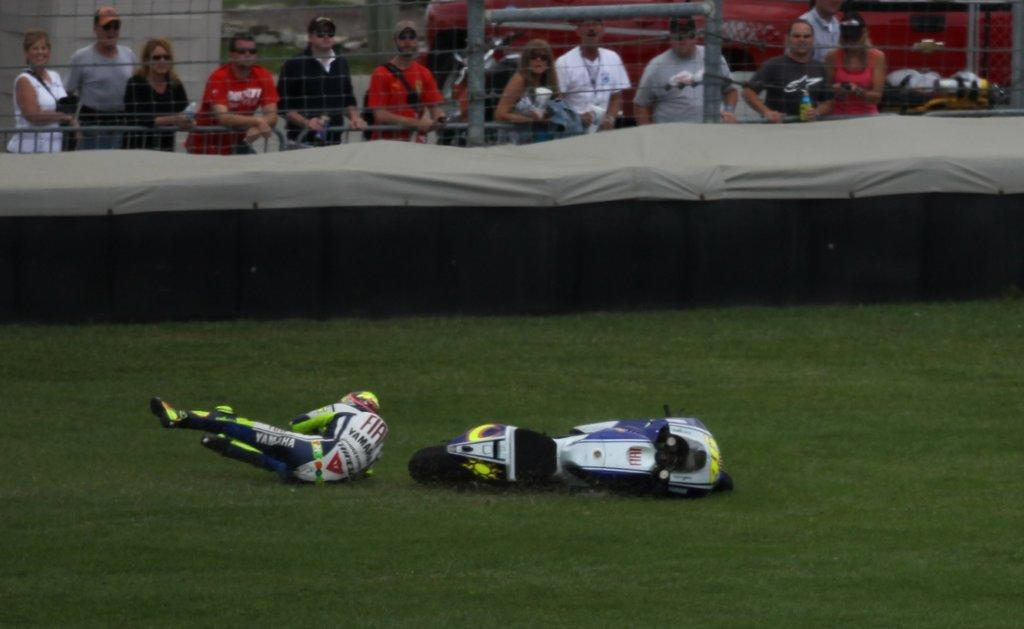What is the main subject in the image? There is a person in the image. What object is on the ground near the person? There is a bike on the ground in the image. What type of material is visible in the image? There is cloth visible in the image. What type of barrier can be seen in the image? There is a fence in the image. How many people are present in the image? There are few persons in the image. What type of poison is being used by the person in the image? There is no poison present in the image; it is not mentioned or depicted. 